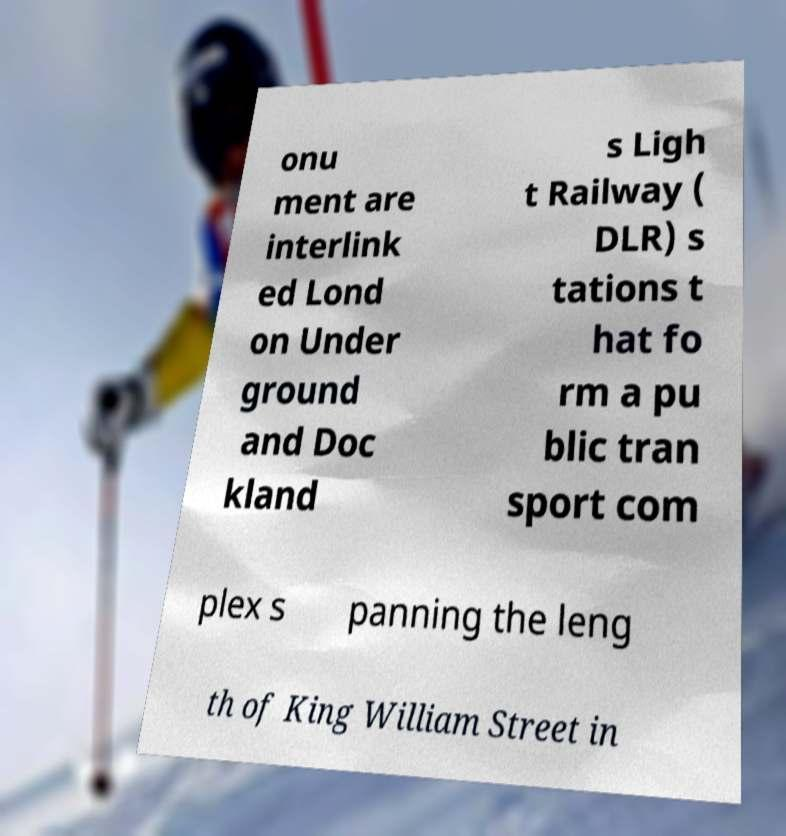Please read and relay the text visible in this image. What does it say? onu ment are interlink ed Lond on Under ground and Doc kland s Ligh t Railway ( DLR) s tations t hat fo rm a pu blic tran sport com plex s panning the leng th of King William Street in 